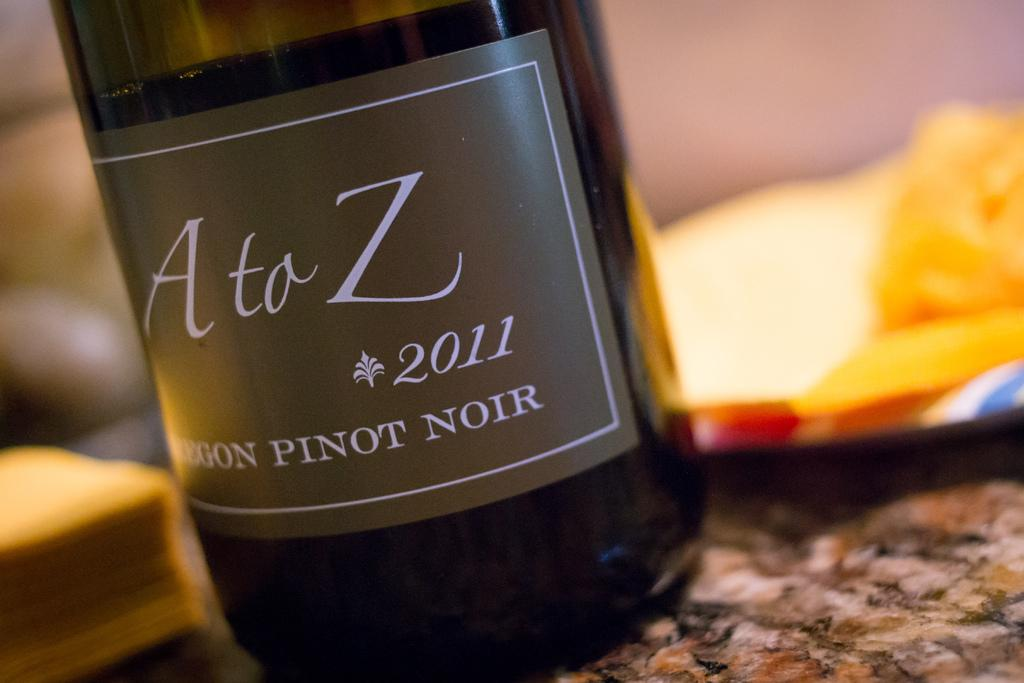<image>
Describe the image concisely. the year 2011 that is on a wine bottle 